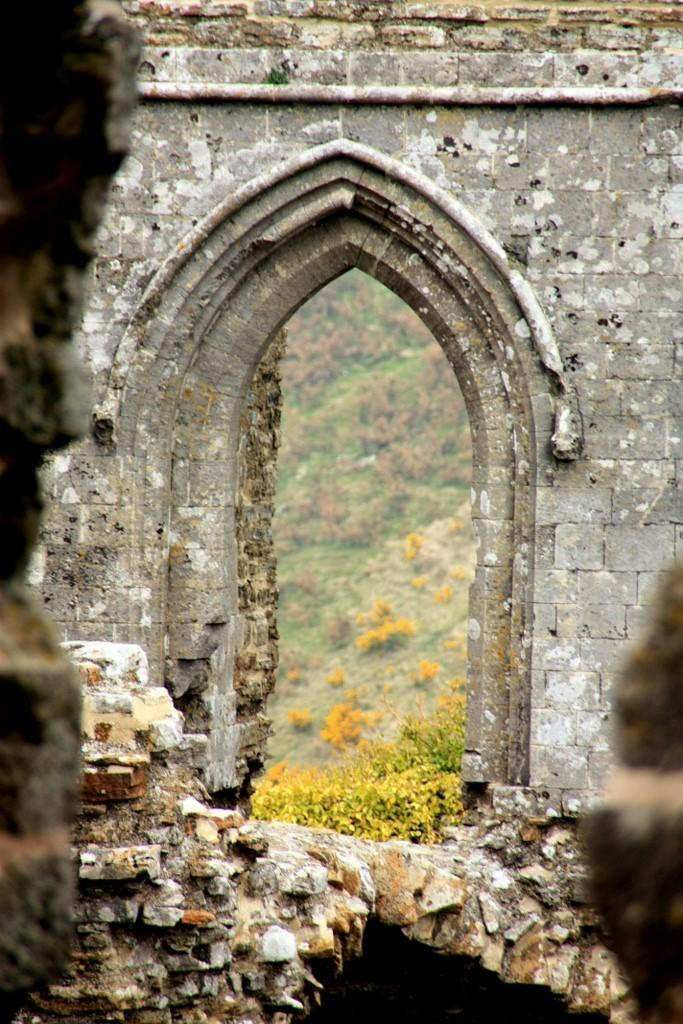What is the main subject of the image? There is a monument in the image. What can be seen in the background of the image? There is a mountain and plants in the background of the image. What type of vegetation is present in the background? There is grass in the background of the image. What type of mask is being worn by the monument in the image? There is no mask present in the image, as the main subject is a monument, which is an inanimate object. 